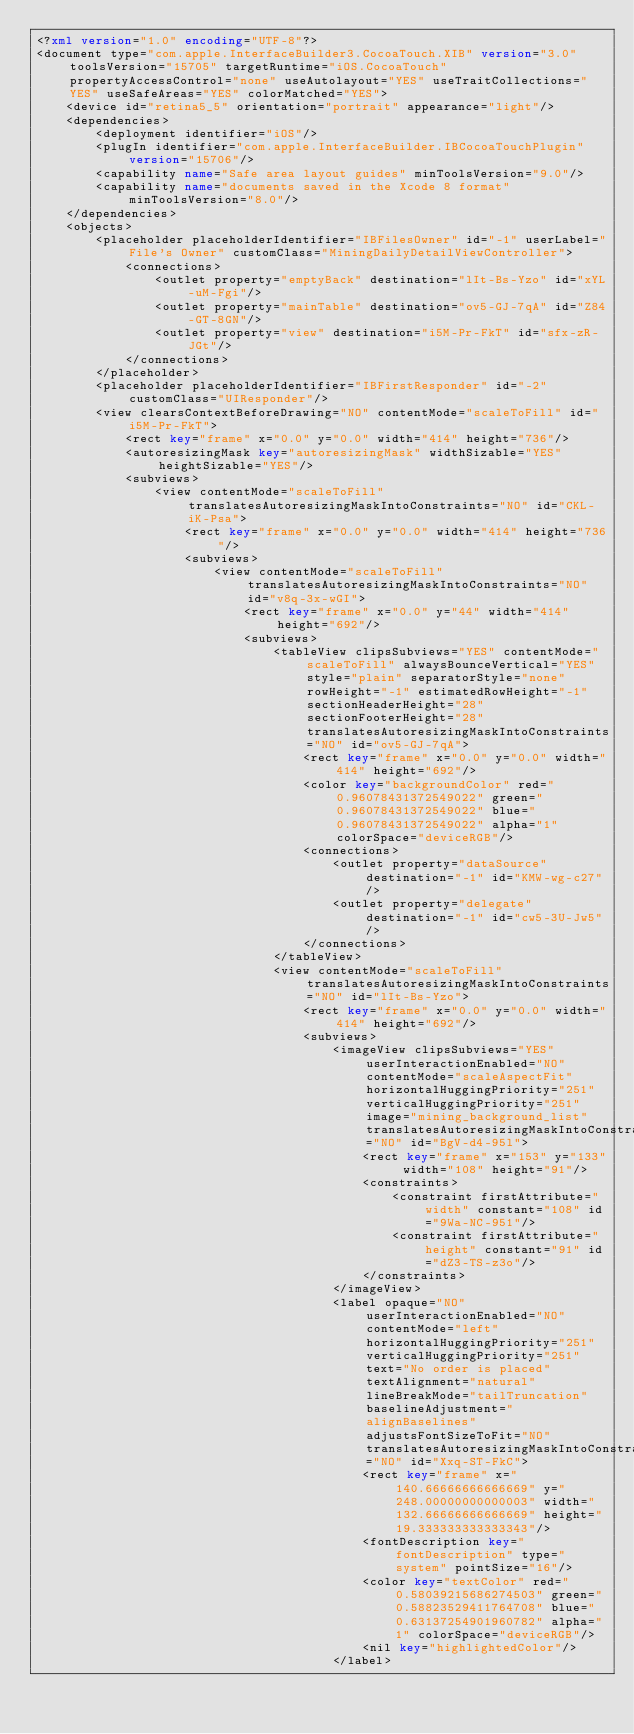Convert code to text. <code><loc_0><loc_0><loc_500><loc_500><_XML_><?xml version="1.0" encoding="UTF-8"?>
<document type="com.apple.InterfaceBuilder3.CocoaTouch.XIB" version="3.0" toolsVersion="15705" targetRuntime="iOS.CocoaTouch" propertyAccessControl="none" useAutolayout="YES" useTraitCollections="YES" useSafeAreas="YES" colorMatched="YES">
    <device id="retina5_5" orientation="portrait" appearance="light"/>
    <dependencies>
        <deployment identifier="iOS"/>
        <plugIn identifier="com.apple.InterfaceBuilder.IBCocoaTouchPlugin" version="15706"/>
        <capability name="Safe area layout guides" minToolsVersion="9.0"/>
        <capability name="documents saved in the Xcode 8 format" minToolsVersion="8.0"/>
    </dependencies>
    <objects>
        <placeholder placeholderIdentifier="IBFilesOwner" id="-1" userLabel="File's Owner" customClass="MiningDailyDetailViewController">
            <connections>
                <outlet property="emptyBack" destination="lIt-Bs-Yzo" id="xYL-uM-Fgi"/>
                <outlet property="mainTable" destination="ov5-GJ-7qA" id="Z84-GT-8GN"/>
                <outlet property="view" destination="i5M-Pr-FkT" id="sfx-zR-JGt"/>
            </connections>
        </placeholder>
        <placeholder placeholderIdentifier="IBFirstResponder" id="-2" customClass="UIResponder"/>
        <view clearsContextBeforeDrawing="NO" contentMode="scaleToFill" id="i5M-Pr-FkT">
            <rect key="frame" x="0.0" y="0.0" width="414" height="736"/>
            <autoresizingMask key="autoresizingMask" widthSizable="YES" heightSizable="YES"/>
            <subviews>
                <view contentMode="scaleToFill" translatesAutoresizingMaskIntoConstraints="NO" id="CKL-iK-Psa">
                    <rect key="frame" x="0.0" y="0.0" width="414" height="736"/>
                    <subviews>
                        <view contentMode="scaleToFill" translatesAutoresizingMaskIntoConstraints="NO" id="v8q-3x-wGI">
                            <rect key="frame" x="0.0" y="44" width="414" height="692"/>
                            <subviews>
                                <tableView clipsSubviews="YES" contentMode="scaleToFill" alwaysBounceVertical="YES" style="plain" separatorStyle="none" rowHeight="-1" estimatedRowHeight="-1" sectionHeaderHeight="28" sectionFooterHeight="28" translatesAutoresizingMaskIntoConstraints="NO" id="ov5-GJ-7qA">
                                    <rect key="frame" x="0.0" y="0.0" width="414" height="692"/>
                                    <color key="backgroundColor" red="0.96078431372549022" green="0.96078431372549022" blue="0.96078431372549022" alpha="1" colorSpace="deviceRGB"/>
                                    <connections>
                                        <outlet property="dataSource" destination="-1" id="KMW-wg-c27"/>
                                        <outlet property="delegate" destination="-1" id="cw5-3U-Jw5"/>
                                    </connections>
                                </tableView>
                                <view contentMode="scaleToFill" translatesAutoresizingMaskIntoConstraints="NO" id="lIt-Bs-Yzo">
                                    <rect key="frame" x="0.0" y="0.0" width="414" height="692"/>
                                    <subviews>
                                        <imageView clipsSubviews="YES" userInteractionEnabled="NO" contentMode="scaleAspectFit" horizontalHuggingPriority="251" verticalHuggingPriority="251" image="mining_background_list" translatesAutoresizingMaskIntoConstraints="NO" id="BgV-d4-95l">
                                            <rect key="frame" x="153" y="133" width="108" height="91"/>
                                            <constraints>
                                                <constraint firstAttribute="width" constant="108" id="9Wa-NC-951"/>
                                                <constraint firstAttribute="height" constant="91" id="dZ3-TS-z3o"/>
                                            </constraints>
                                        </imageView>
                                        <label opaque="NO" userInteractionEnabled="NO" contentMode="left" horizontalHuggingPriority="251" verticalHuggingPriority="251" text="No order is placed" textAlignment="natural" lineBreakMode="tailTruncation" baselineAdjustment="alignBaselines" adjustsFontSizeToFit="NO" translatesAutoresizingMaskIntoConstraints="NO" id="Xxq-ST-FkC">
                                            <rect key="frame" x="140.66666666666669" y="248.00000000000003" width="132.66666666666669" height="19.333333333333343"/>
                                            <fontDescription key="fontDescription" type="system" pointSize="16"/>
                                            <color key="textColor" red="0.58039215686274503" green="0.58823529411764708" blue="0.63137254901960782" alpha="1" colorSpace="deviceRGB"/>
                                            <nil key="highlightedColor"/>
                                        </label></code> 